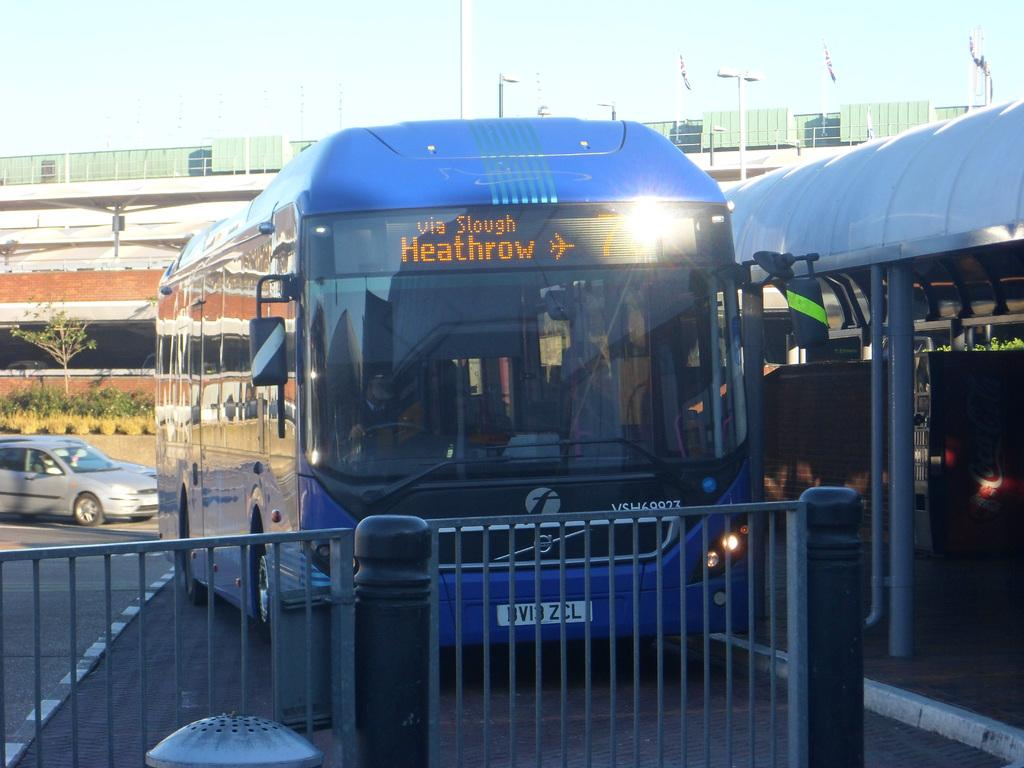<image>
Give a short and clear explanation of the subsequent image. A blue bus at the depot is going to Heathrow via Slough 